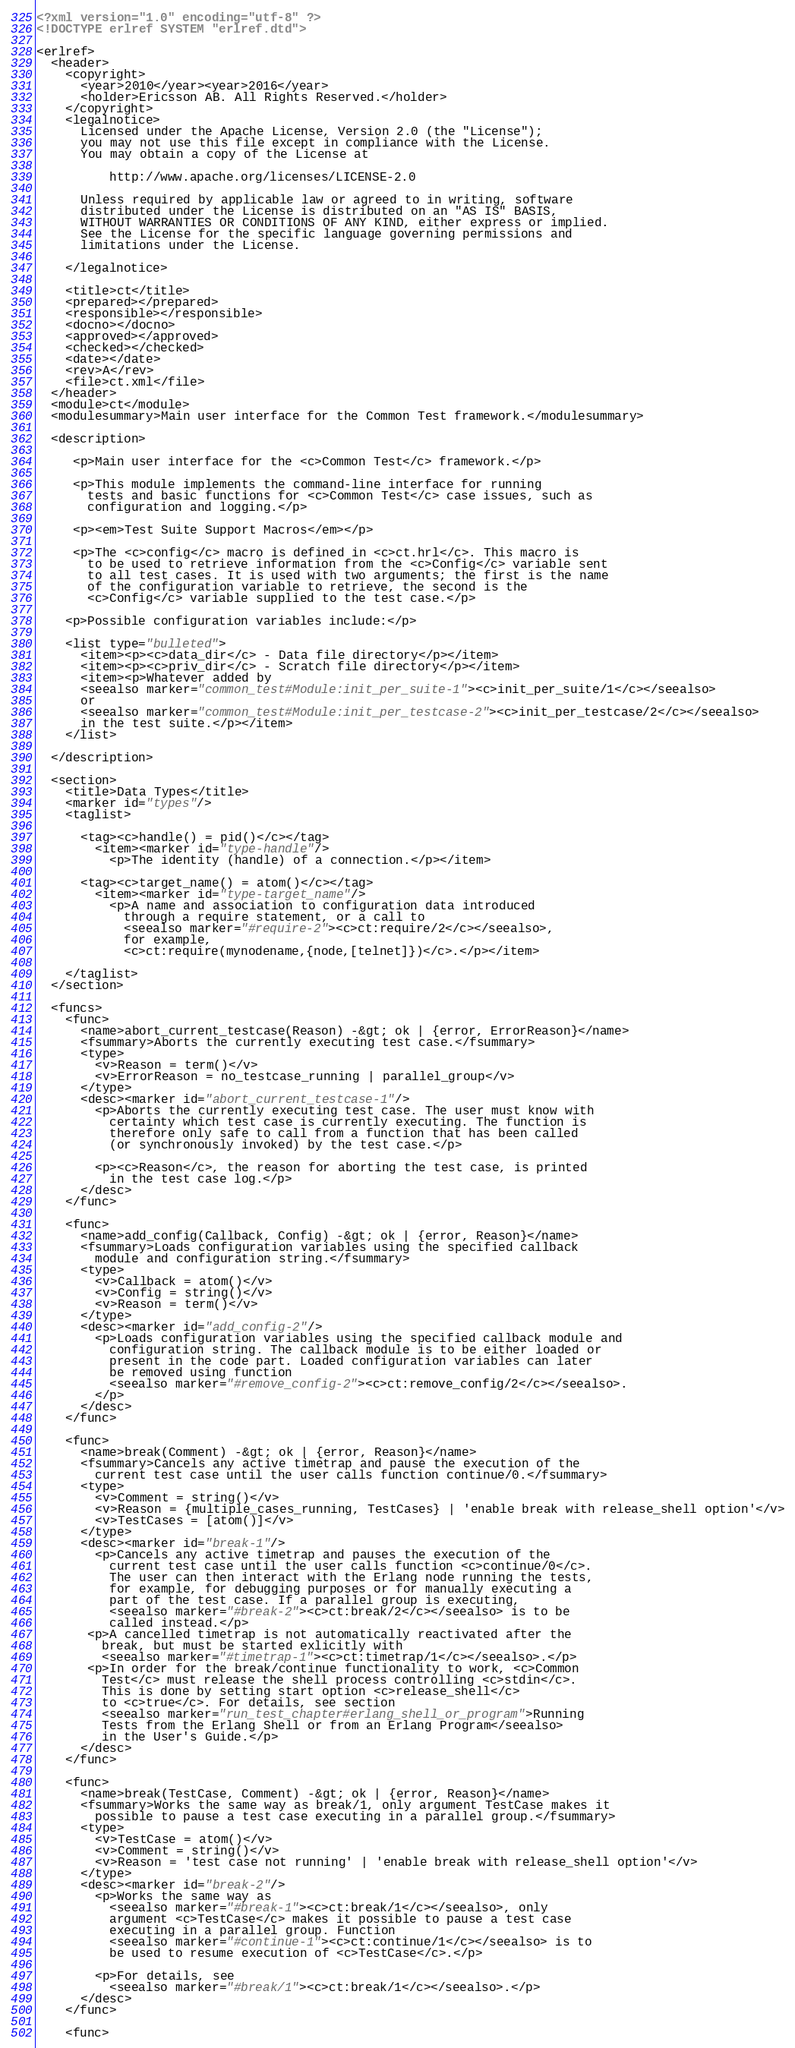<code> <loc_0><loc_0><loc_500><loc_500><_XML_><?xml version="1.0" encoding="utf-8" ?>
<!DOCTYPE erlref SYSTEM "erlref.dtd">

<erlref>
  <header>
    <copyright>
      <year>2010</year><year>2016</year>
      <holder>Ericsson AB. All Rights Reserved.</holder>
    </copyright>
    <legalnotice>
      Licensed under the Apache License, Version 2.0 (the "License");
      you may not use this file except in compliance with the License.
      You may obtain a copy of the License at

          http://www.apache.org/licenses/LICENSE-2.0

      Unless required by applicable law or agreed to in writing, software
      distributed under the License is distributed on an "AS IS" BASIS,
      WITHOUT WARRANTIES OR CONDITIONS OF ANY KIND, either express or implied.
      See the License for the specific language governing permissions and
      limitations under the License.

    </legalnotice>

    <title>ct</title>
    <prepared></prepared>
    <responsible></responsible>
    <docno></docno>
    <approved></approved>
    <checked></checked>
    <date></date>
    <rev>A</rev>
    <file>ct.xml</file>
  </header>
  <module>ct</module>
  <modulesummary>Main user interface for the Common Test framework.</modulesummary>

  <description>

     <p>Main user interface for the <c>Common Test</c> framework.</p>

     <p>This module implements the command-line interface for running
       tests and basic functions for <c>Common Test</c> case issues, such as
       configuration and logging.</p>

     <p><em>Test Suite Support Macros</em></p> 

     <p>The <c>config</c> macro is defined in <c>ct.hrl</c>. This macro is
       to be used to retrieve information from the <c>Config</c> variable sent
       to all test cases. It is used with two arguments; the first is the name
       of the configuration variable to retrieve, the second is the
       <c>Config</c> variable supplied to the test case.</p>

    <p>Possible configuration variables include:</p>

    <list type="bulleted">
      <item><p><c>data_dir</c> - Data file directory</p></item>
      <item><p><c>priv_dir</c> - Scratch file directory</p></item>
      <item><p>Whatever added by
      <seealso marker="common_test#Module:init_per_suite-1"><c>init_per_suite/1</c></seealso>
      or
      <seealso marker="common_test#Module:init_per_testcase-2"><c>init_per_testcase/2</c></seealso>
      in the test suite.</p></item>
    </list>

  </description>

  <section>
    <title>Data Types</title>
    <marker id="types"/>
    <taglist>

      <tag><c>handle() = pid()</c></tag>
        <item><marker id="type-handle"/>
          <p>The identity (handle) of a connection.</p></item>

      <tag><c>target_name() = atom()</c></tag>
        <item><marker id="type-target_name"/>
          <p>A name and association to configuration data introduced
            through a require statement, or a call to
            <seealso marker="#require-2"><c>ct:require/2</c></seealso>,
            for example,
            <c>ct:require(mynodename,{node,[telnet]})</c>.</p></item>

    </taglist>
  </section>

  <funcs>
    <func>
      <name>abort_current_testcase(Reason) -&gt; ok | {error, ErrorReason}</name>
      <fsummary>Aborts the currently executing test case.</fsummary>
      <type>
        <v>Reason = term()</v>
        <v>ErrorReason = no_testcase_running | parallel_group</v>
      </type>
      <desc><marker id="abort_current_testcase-1"/>
        <p>Aborts the currently executing test case. The user must know with
          certainty which test case is currently executing. The function is
          therefore only safe to call from a function that has been called
          (or synchronously invoked) by the test case.</p>

        <p><c>Reason</c>, the reason for aborting the test case, is printed
          in the test case log.</p>
      </desc>
    </func>

    <func>
      <name>add_config(Callback, Config) -&gt; ok | {error, Reason}</name>
      <fsummary>Loads configuration variables using the specified callback
        module and configuration string.</fsummary>
      <type>
        <v>Callback = atom()</v>
        <v>Config = string()</v>
        <v>Reason = term()</v>
      </type>
      <desc><marker id="add_config-2"/>
        <p>Loads configuration variables using the specified callback module and
          configuration string. The callback module is to be either loaded or
          present in the code part. Loaded configuration variables can later
          be removed using function
          <seealso marker="#remove_config-2"><c>ct:remove_config/2</c></seealso>.
        </p>
      </desc>
    </func>

    <func>
      <name>break(Comment) -&gt; ok | {error, Reason}</name>
      <fsummary>Cancels any active timetrap and pause the execution of the
        current test case until the user calls function continue/0.</fsummary>
      <type>
        <v>Comment = string()</v>
        <v>Reason = {multiple_cases_running, TestCases} | 'enable break with release_shell option'</v>
        <v>TestCases = [atom()]</v>
      </type>
      <desc><marker id="break-1"/>
        <p>Cancels any active timetrap and pauses the execution of the
          current test case until the user calls function <c>continue/0</c>.
          The user can then interact with the Erlang node running the tests,
          for example, for debugging purposes or for manually executing a
          part of the test case. If a parallel group is executing,
          <seealso marker="#break-2"><c>ct:break/2</c></seealso> is to be
          called instead.</p>
       <p>A cancelled timetrap is not automatically reactivated after the
         break, but must be started exlicitly with
         <seealso marker="#timetrap-1"><c>ct:timetrap/1</c></seealso>.</p>
       <p>In order for the break/continue functionality to work, <c>Common
         Test</c> must release the shell process controlling <c>stdin</c>.
         This is done by setting start option <c>release_shell</c>
         to <c>true</c>. For details, see section
         <seealso marker="run_test_chapter#erlang_shell_or_program">Running
         Tests from the Erlang Shell or from an Erlang Program</seealso>
         in the User's Guide.</p>
      </desc>
    </func>

    <func>
      <name>break(TestCase, Comment) -&gt; ok | {error, Reason}</name>
      <fsummary>Works the same way as break/1, only argument TestCase makes it
        possible to pause a test case executing in a parallel group.</fsummary>
      <type>
        <v>TestCase = atom()</v>
        <v>Comment = string()</v>
        <v>Reason = 'test case not running' | 'enable break with release_shell option'</v>
      </type>
      <desc><marker id="break-2"/>
        <p>Works the same way as
          <seealso marker="#break-1"><c>ct:break/1</c></seealso>, only
          argument <c>TestCase</c> makes it possible to pause a test case
          executing in a parallel group. Function
          <seealso marker="#continue-1"><c>ct:continue/1</c></seealso> is to
          be used to resume execution of <c>TestCase</c>.</p>

        <p>For details, see
          <seealso marker="#break/1"><c>ct:break/1</c></seealso>.</p>
      </desc>
    </func>

    <func></code> 